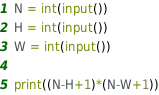Convert code to text. <code><loc_0><loc_0><loc_500><loc_500><_Python_>N = int(input())
H = int(input())
W = int(input())

print((N-H+1)*(N-W+1))</code> 